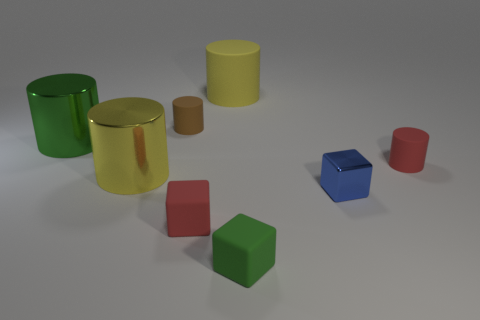What is the shape of the small object that is behind the thing right of the small cube to the right of the green matte cube?
Offer a terse response. Cylinder. What size is the object to the right of the blue cube?
Offer a terse response. Small. There is a blue object that is the same size as the green rubber object; what shape is it?
Offer a terse response. Cube. How many things are gray metal cylinders or tiny red matte objects that are in front of the yellow shiny object?
Provide a short and direct response. 1. There is a tiny red thing that is right of the small red object that is in front of the tiny blue metal block; what number of small red objects are to the right of it?
Make the answer very short. 0. What color is the large cylinder that is the same material as the tiny brown cylinder?
Your response must be concise. Yellow. Is the size of the metal thing that is left of the yellow shiny cylinder the same as the green cube?
Your answer should be compact. No. What number of objects are either large yellow shiny things or spheres?
Your answer should be very brief. 1. The large yellow thing that is behind the big yellow object that is left of the large yellow thing that is behind the yellow metal thing is made of what material?
Provide a short and direct response. Rubber. What is the small cube that is left of the green cube made of?
Provide a succinct answer. Rubber. 